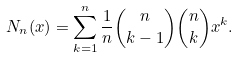Convert formula to latex. <formula><loc_0><loc_0><loc_500><loc_500>N _ { n } ( x ) = \sum _ { k = 1 } ^ { n } \frac { 1 } { n } \binom { n } { k - 1 } \binom { n } { k } x ^ { k } .</formula> 